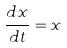Convert formula to latex. <formula><loc_0><loc_0><loc_500><loc_500>\frac { d x } { d t } = x</formula> 